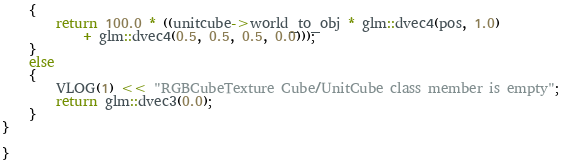<code> <loc_0><loc_0><loc_500><loc_500><_C++_>	{
		return 100.0 * ((unitcube->world_to_obj * glm::dvec4(pos, 1.0)
			+ glm::dvec4(0.5, 0.5, 0.5, 0.0)));
	}
	else
	{
		VLOG(1) << "RGBCubeTexture Cube/UnitCube class member is empty";
		return glm::dvec3(0.0);
	}
}

}</code> 